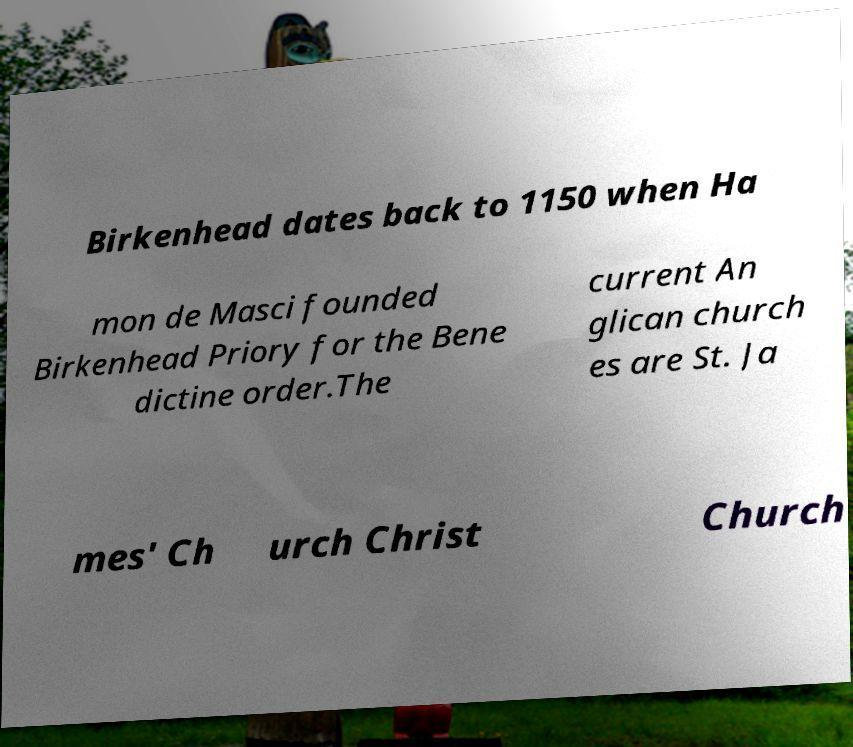Could you assist in decoding the text presented in this image and type it out clearly? Birkenhead dates back to 1150 when Ha mon de Masci founded Birkenhead Priory for the Bene dictine order.The current An glican church es are St. Ja mes' Ch urch Christ Church 